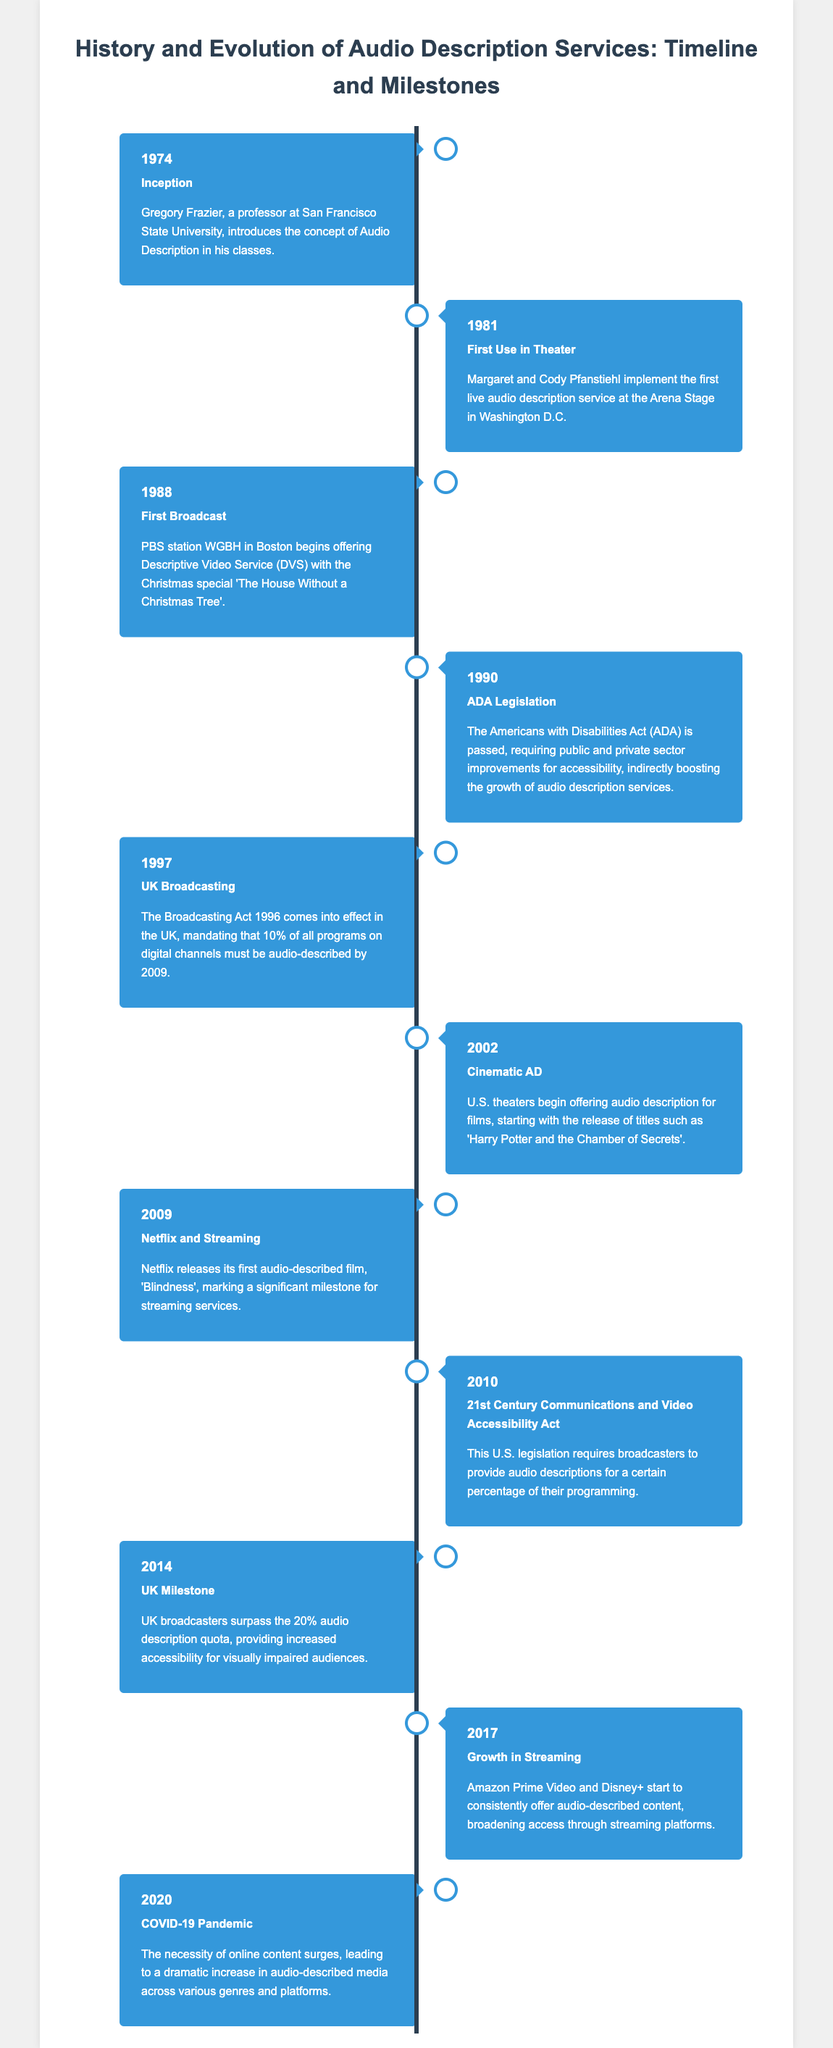what year was the concept of Audio Description introduced? The inception event in the timeline shows that Gregory Frazier introduced the concept in 1974.
Answer: 1974 who implemented the first live audio description service? The first use in theater section mentions Margaret and Cody Pfanstiehl as the implementers.
Answer: Margaret and Cody Pfanstiehl what significant piece of legislation was passed in 1990? The ADA legislation section indicates that the Americans with Disabilities Act was passed, which is a key moment.
Answer: Americans with Disabilities Act which organization began offering Descriptive Video Service in 1988? The first broadcast section states that PBS station WGBH in Boston began DVS services.
Answer: PBS station WGBH what percentage of programs must be audio-described by 2009 according to the UK Broadcasting Act? The UK Broadcasting section specifies that 10% of all programs must be audio-described.
Answer: 10% how many audio-described films did Netflix release in 2009? The Netflix and Streaming section indicates that Netflix released its first audio-described film, which is one film.
Answer: one which platform started offering consistent audio-described content in 2017? The Growth in Streaming section mentions Amazon Prime Video and Disney+ as the platforms that started offering this content.
Answer: Amazon Prime Video and Disney+ what event in 2020 led to a surge in online content? The COVID-19 Pandemic section highlights that the pandemic increased the necessity for online content.
Answer: COVID-19 Pandemic what is the primary focus of the infographic? The title of the document clearly states that the focus is on the history and evolution of audio description services.
Answer: History and evolution of audio description services 